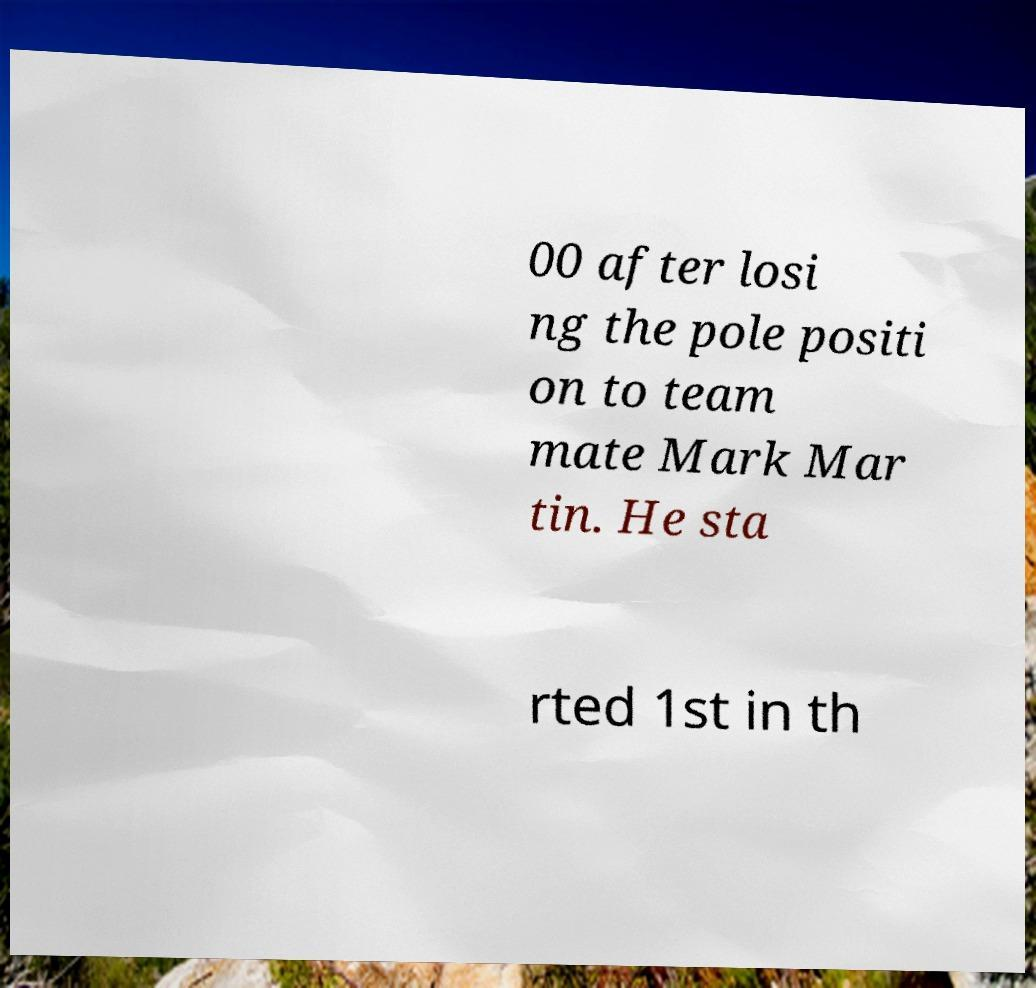For documentation purposes, I need the text within this image transcribed. Could you provide that? 00 after losi ng the pole positi on to team mate Mark Mar tin. He sta rted 1st in th 